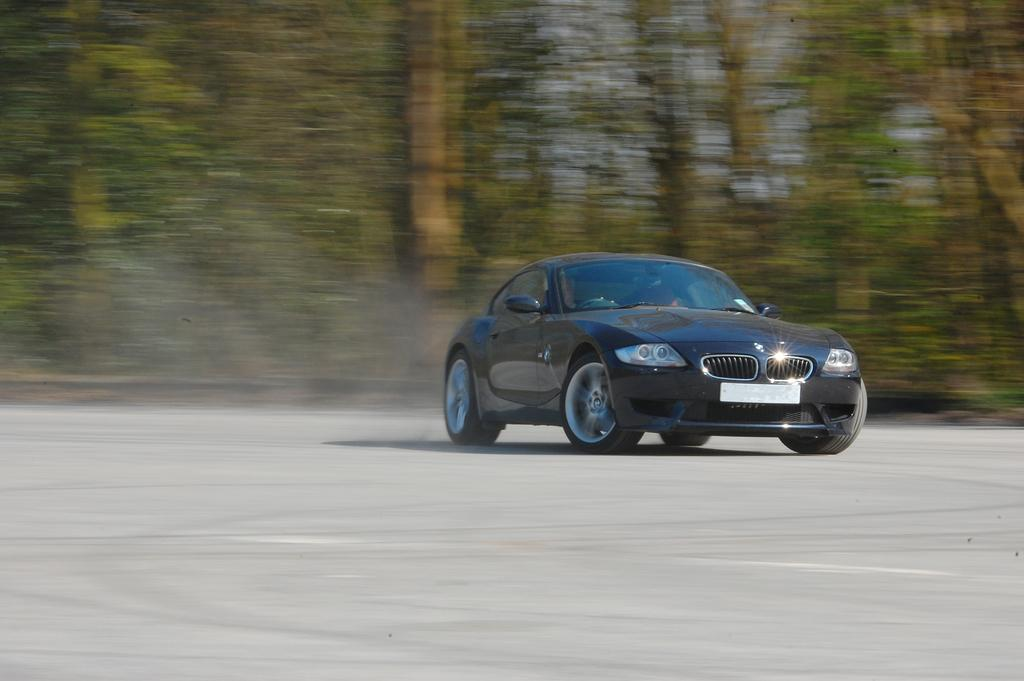What is the main subject of the image? There is a black car in the center of the image. Where is the car located? The car is on the road. What can be seen in the background of the image? There are trees, smoke, and a few other objects in the background of the image. Is there a bear sleeping on the car in the image? No, there is no bear or any indication of sleeping in the image. The image only shows a black car on the road with trees and smoke in the background. 